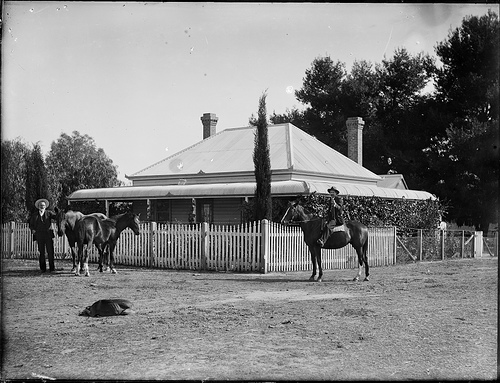How many horses are pictured? There are three horses captured in the image, standing gracefully in what appears to be a residential area, possibly depicting a rural or countryside setting. 